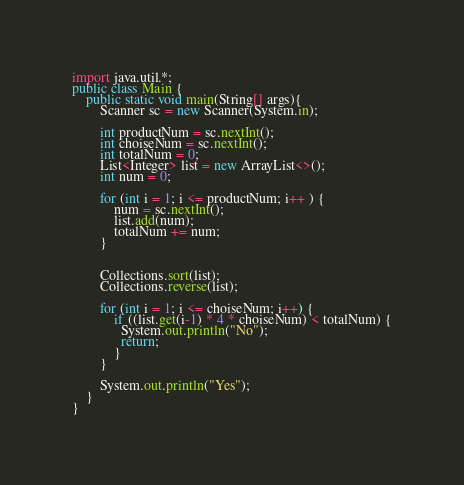<code> <loc_0><loc_0><loc_500><loc_500><_Java_>import java.util.*;
public class Main {
	public static void main(String[] args){
		Scanner sc = new Scanner(System.in);

		int productNum = sc.nextInt();
		int choiseNum = sc.nextInt();
		int totalNum = 0;
		List<Integer> list = new ArrayList<>();
		int num = 0;

		for (int i = 1; i <= productNum; i++ ) {
			num = sc.nextInt();
			list.add(num);
			totalNum += num;
		}


		Collections.sort(list);
		Collections.reverse(list);
		
		for (int i = 1; i <= choiseNum; i++) {
		    if ((list.get(i-1) * 4 * choiseNum) < totalNum) {
		      System.out.println("No");
		      return;  
		    }
		}
		
		System.out.println("Yes");
	}
}</code> 